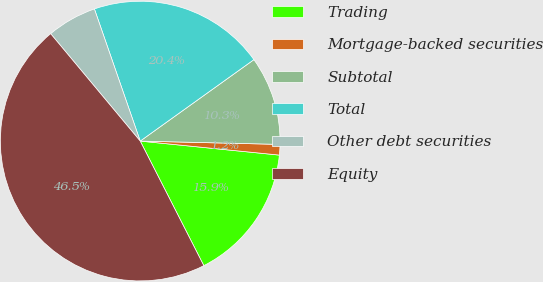<chart> <loc_0><loc_0><loc_500><loc_500><pie_chart><fcel>Trading<fcel>Mortgage-backed securities<fcel>Subtotal<fcel>Total<fcel>Other debt securities<fcel>Equity<nl><fcel>15.89%<fcel>1.22%<fcel>10.27%<fcel>20.42%<fcel>5.75%<fcel>46.45%<nl></chart> 